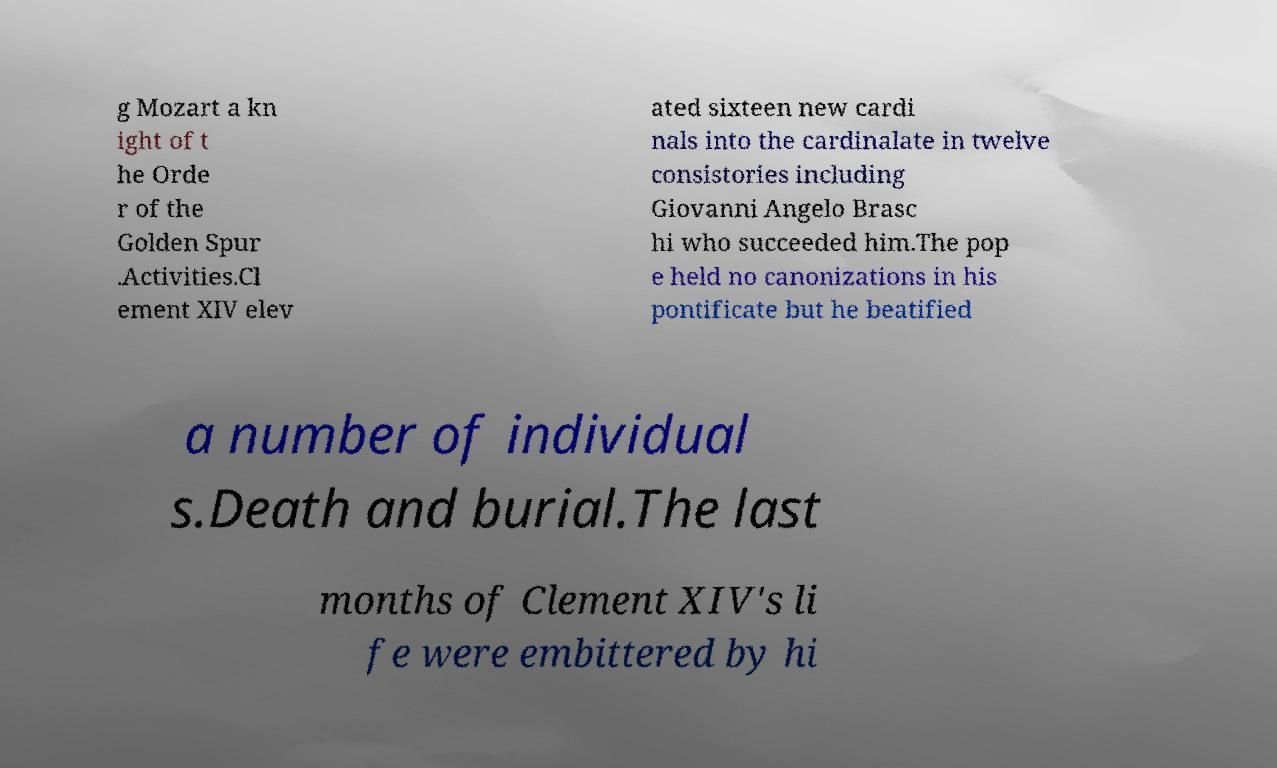Please read and relay the text visible in this image. What does it say? g Mozart a kn ight of t he Orde r of the Golden Spur .Activities.Cl ement XIV elev ated sixteen new cardi nals into the cardinalate in twelve consistories including Giovanni Angelo Brasc hi who succeeded him.The pop e held no canonizations in his pontificate but he beatified a number of individual s.Death and burial.The last months of Clement XIV's li fe were embittered by hi 